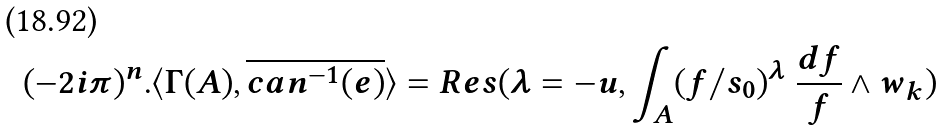<formula> <loc_0><loc_0><loc_500><loc_500>( - 2 i \pi ) ^ { n } . \langle \Gamma ( A ) , \overline { c a n ^ { - 1 } ( e ) } \rangle = R e s ( \lambda = - u , \int _ { A } ( f / s _ { 0 } ) ^ { \lambda } \ \frac { d f } { f } \wedge w _ { k } )</formula> 